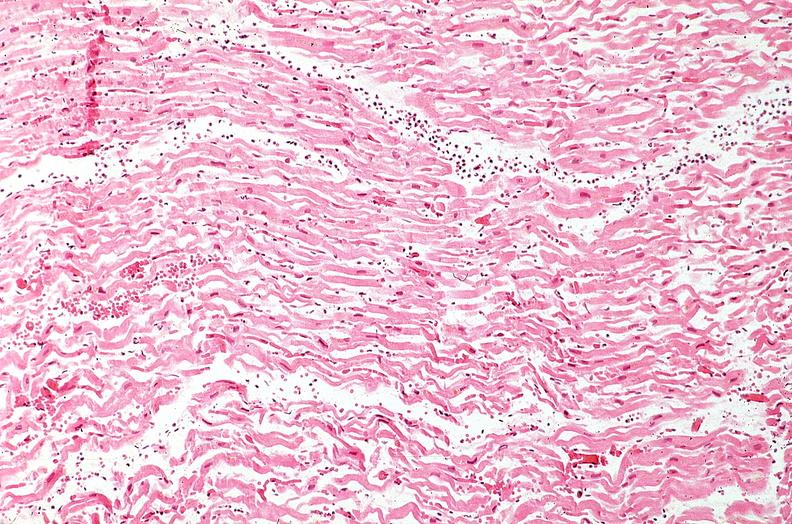what does this image show?
Answer the question using a single word or phrase. Heart 